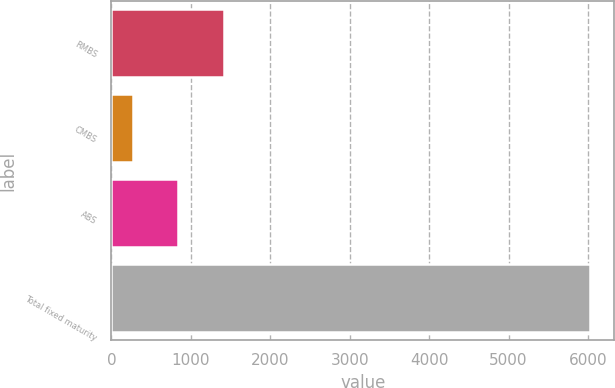Convert chart to OTSL. <chart><loc_0><loc_0><loc_500><loc_500><bar_chart><fcel>RMBS<fcel>CMBS<fcel>ABS<fcel>Total fixed maturity<nl><fcel>1418.8<fcel>266<fcel>842.4<fcel>6030<nl></chart> 